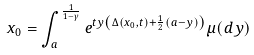Convert formula to latex. <formula><loc_0><loc_0><loc_500><loc_500>x _ { 0 } = \int _ { a } ^ { \frac { 1 } { 1 - \gamma } } e ^ { t y \left ( \Delta \left ( x _ { 0 } , t \right ) + \frac { 1 } { 2 } \left ( a - y \right ) \right ) } \mu ( d y )</formula> 